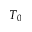Convert formula to latex. <formula><loc_0><loc_0><loc_500><loc_500>T _ { 0 }</formula> 